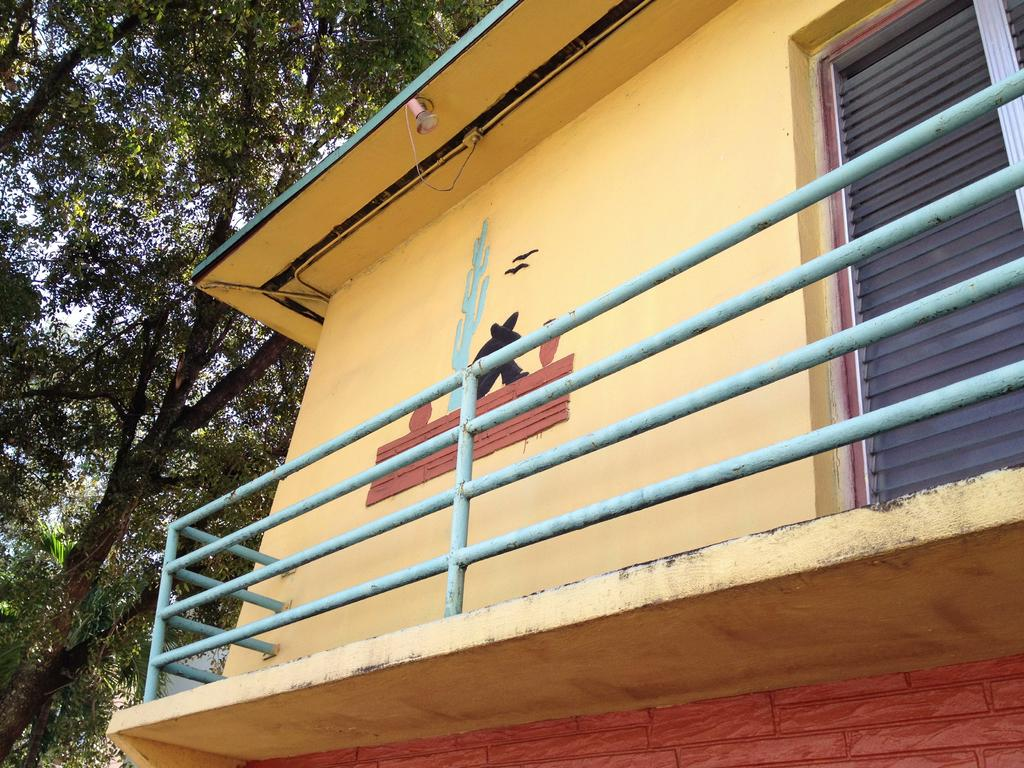What type of structure is present in the image? There is a house in the image. What other natural elements can be seen in the image? There are trees in the image. What is visible in the background of the image? The sky is visible in the background of the image. How many horses are tied to the string in the image? There are no horses or strings present in the image. 